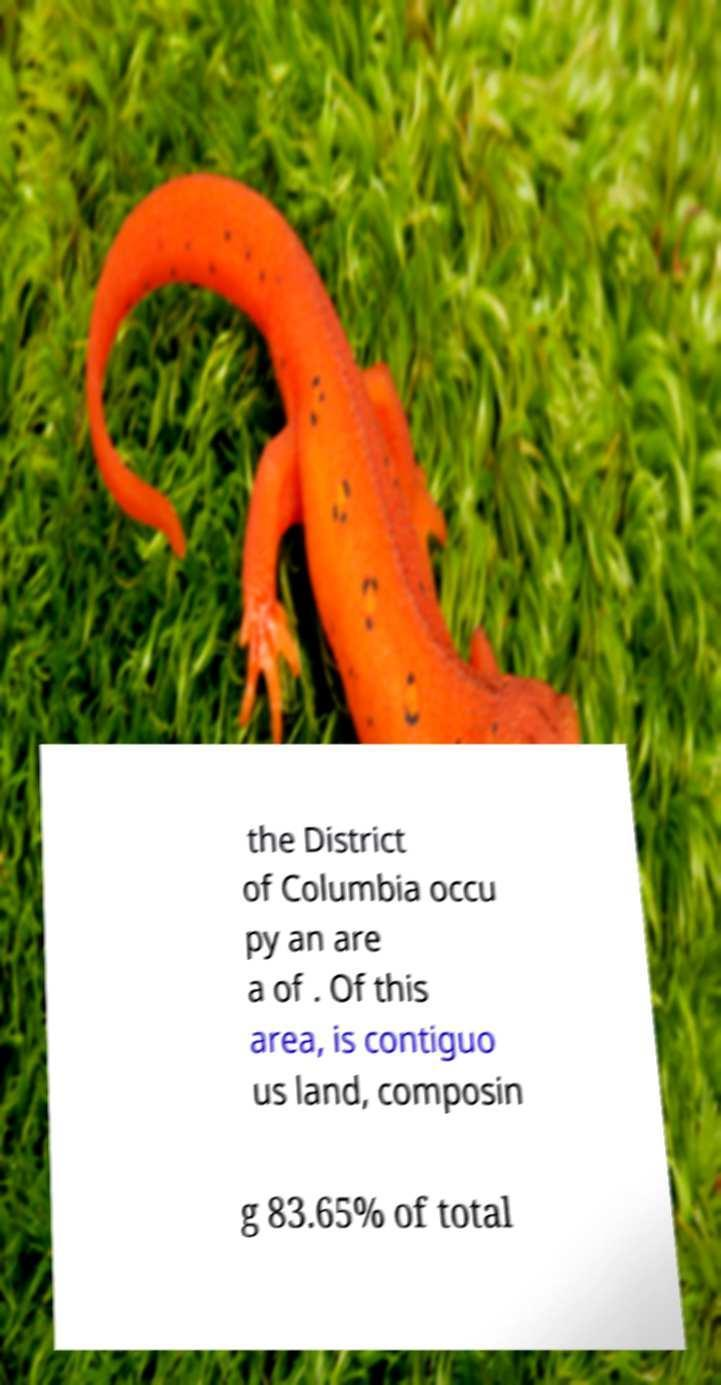Could you assist in decoding the text presented in this image and type it out clearly? the District of Columbia occu py an are a of . Of this area, is contiguo us land, composin g 83.65% of total 